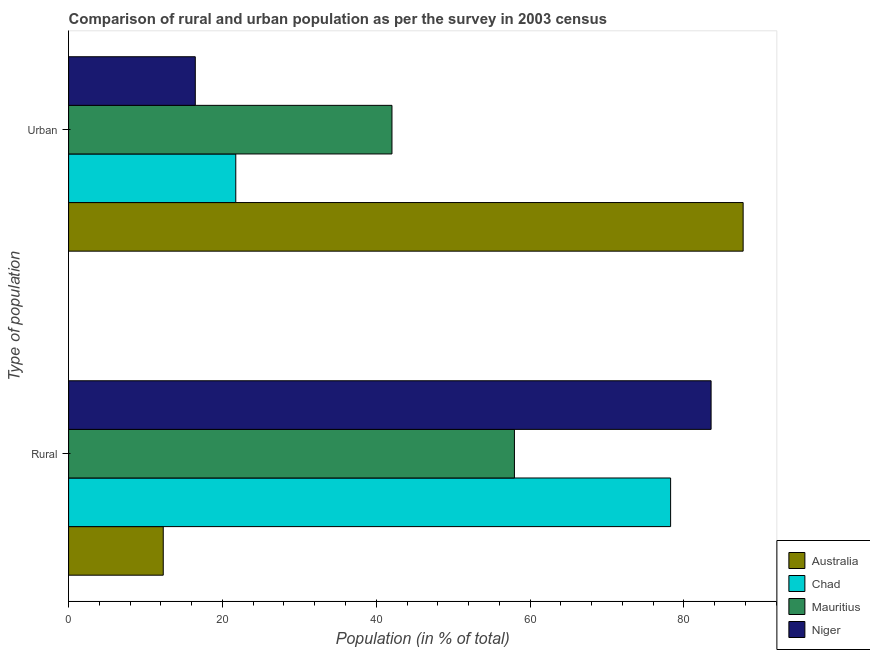How many different coloured bars are there?
Your answer should be compact. 4. How many groups of bars are there?
Ensure brevity in your answer.  2. Are the number of bars per tick equal to the number of legend labels?
Provide a succinct answer. Yes. What is the label of the 2nd group of bars from the top?
Offer a terse response. Rural. What is the urban population in Australia?
Offer a very short reply. 87.69. Across all countries, what is the maximum rural population?
Your response must be concise. 83.53. Across all countries, what is the minimum urban population?
Your answer should be compact. 16.47. In which country was the urban population maximum?
Provide a short and direct response. Australia. What is the total rural population in the graph?
Offer a very short reply. 232.06. What is the difference between the urban population in Niger and that in Chad?
Provide a short and direct response. -5.26. What is the difference between the urban population in Niger and the rural population in Chad?
Your answer should be very brief. -61.79. What is the average urban population per country?
Offer a very short reply. 41.99. What is the difference between the urban population and rural population in Niger?
Offer a very short reply. -67.06. What is the ratio of the rural population in Chad to that in Mauritius?
Ensure brevity in your answer.  1.35. What does the 3rd bar from the top in Urban represents?
Make the answer very short. Chad. What does the 2nd bar from the bottom in Rural represents?
Keep it short and to the point. Chad. How many bars are there?
Offer a very short reply. 8. What is the difference between two consecutive major ticks on the X-axis?
Ensure brevity in your answer.  20. Are the values on the major ticks of X-axis written in scientific E-notation?
Your answer should be very brief. No. Does the graph contain any zero values?
Offer a terse response. No. How many legend labels are there?
Make the answer very short. 4. How are the legend labels stacked?
Give a very brief answer. Vertical. What is the title of the graph?
Your answer should be very brief. Comparison of rural and urban population as per the survey in 2003 census. What is the label or title of the X-axis?
Your answer should be compact. Population (in % of total). What is the label or title of the Y-axis?
Offer a very short reply. Type of population. What is the Population (in % of total) of Australia in Rural?
Offer a very short reply. 12.3. What is the Population (in % of total) in Chad in Rural?
Give a very brief answer. 78.27. What is the Population (in % of total) in Mauritius in Rural?
Keep it short and to the point. 57.96. What is the Population (in % of total) in Niger in Rural?
Your answer should be compact. 83.53. What is the Population (in % of total) in Australia in Urban?
Give a very brief answer. 87.69. What is the Population (in % of total) of Chad in Urban?
Give a very brief answer. 21.73. What is the Population (in % of total) in Mauritius in Urban?
Make the answer very short. 42.04. What is the Population (in % of total) in Niger in Urban?
Your response must be concise. 16.47. Across all Type of population, what is the maximum Population (in % of total) in Australia?
Your answer should be compact. 87.69. Across all Type of population, what is the maximum Population (in % of total) in Chad?
Offer a very short reply. 78.27. Across all Type of population, what is the maximum Population (in % of total) of Mauritius?
Keep it short and to the point. 57.96. Across all Type of population, what is the maximum Population (in % of total) in Niger?
Your answer should be compact. 83.53. Across all Type of population, what is the minimum Population (in % of total) in Australia?
Ensure brevity in your answer.  12.3. Across all Type of population, what is the minimum Population (in % of total) in Chad?
Provide a short and direct response. 21.73. Across all Type of population, what is the minimum Population (in % of total) of Mauritius?
Your answer should be compact. 42.04. Across all Type of population, what is the minimum Population (in % of total) in Niger?
Your answer should be very brief. 16.47. What is the total Population (in % of total) of Australia in the graph?
Your answer should be compact. 100. What is the total Population (in % of total) of Chad in the graph?
Provide a succinct answer. 100. What is the difference between the Population (in % of total) of Australia in Rural and that in Urban?
Your answer should be very brief. -75.39. What is the difference between the Population (in % of total) of Chad in Rural and that in Urban?
Make the answer very short. 56.53. What is the difference between the Population (in % of total) of Mauritius in Rural and that in Urban?
Your answer should be compact. 15.92. What is the difference between the Population (in % of total) in Niger in Rural and that in Urban?
Your answer should be very brief. 67.06. What is the difference between the Population (in % of total) in Australia in Rural and the Population (in % of total) in Chad in Urban?
Offer a terse response. -9.43. What is the difference between the Population (in % of total) in Australia in Rural and the Population (in % of total) in Mauritius in Urban?
Make the answer very short. -29.73. What is the difference between the Population (in % of total) of Australia in Rural and the Population (in % of total) of Niger in Urban?
Your answer should be compact. -4.17. What is the difference between the Population (in % of total) of Chad in Rural and the Population (in % of total) of Mauritius in Urban?
Give a very brief answer. 36.23. What is the difference between the Population (in % of total) in Chad in Rural and the Population (in % of total) in Niger in Urban?
Your answer should be very brief. 61.79. What is the difference between the Population (in % of total) in Mauritius in Rural and the Population (in % of total) in Niger in Urban?
Provide a succinct answer. 41.49. What is the average Population (in % of total) of Mauritius per Type of population?
Your response must be concise. 50. What is the difference between the Population (in % of total) of Australia and Population (in % of total) of Chad in Rural?
Your answer should be very brief. -65.96. What is the difference between the Population (in % of total) in Australia and Population (in % of total) in Mauritius in Rural?
Give a very brief answer. -45.66. What is the difference between the Population (in % of total) of Australia and Population (in % of total) of Niger in Rural?
Give a very brief answer. -71.22. What is the difference between the Population (in % of total) of Chad and Population (in % of total) of Mauritius in Rural?
Your answer should be compact. 20.3. What is the difference between the Population (in % of total) in Chad and Population (in % of total) in Niger in Rural?
Your response must be concise. -5.26. What is the difference between the Population (in % of total) of Mauritius and Population (in % of total) of Niger in Rural?
Your answer should be very brief. -25.57. What is the difference between the Population (in % of total) in Australia and Population (in % of total) in Chad in Urban?
Ensure brevity in your answer.  65.96. What is the difference between the Population (in % of total) in Australia and Population (in % of total) in Mauritius in Urban?
Provide a succinct answer. 45.66. What is the difference between the Population (in % of total) of Australia and Population (in % of total) of Niger in Urban?
Give a very brief answer. 71.22. What is the difference between the Population (in % of total) in Chad and Population (in % of total) in Mauritius in Urban?
Your answer should be very brief. -20.3. What is the difference between the Population (in % of total) in Chad and Population (in % of total) in Niger in Urban?
Provide a succinct answer. 5.26. What is the difference between the Population (in % of total) of Mauritius and Population (in % of total) of Niger in Urban?
Your response must be concise. 25.57. What is the ratio of the Population (in % of total) in Australia in Rural to that in Urban?
Keep it short and to the point. 0.14. What is the ratio of the Population (in % of total) in Chad in Rural to that in Urban?
Your response must be concise. 3.6. What is the ratio of the Population (in % of total) of Mauritius in Rural to that in Urban?
Give a very brief answer. 1.38. What is the ratio of the Population (in % of total) in Niger in Rural to that in Urban?
Make the answer very short. 5.07. What is the difference between the highest and the second highest Population (in % of total) of Australia?
Your response must be concise. 75.39. What is the difference between the highest and the second highest Population (in % of total) of Chad?
Give a very brief answer. 56.53. What is the difference between the highest and the second highest Population (in % of total) of Mauritius?
Your response must be concise. 15.92. What is the difference between the highest and the second highest Population (in % of total) in Niger?
Your answer should be compact. 67.06. What is the difference between the highest and the lowest Population (in % of total) in Australia?
Your answer should be compact. 75.39. What is the difference between the highest and the lowest Population (in % of total) in Chad?
Provide a succinct answer. 56.53. What is the difference between the highest and the lowest Population (in % of total) in Mauritius?
Ensure brevity in your answer.  15.92. What is the difference between the highest and the lowest Population (in % of total) of Niger?
Keep it short and to the point. 67.06. 